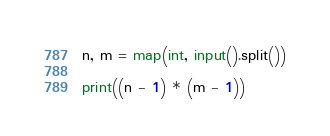<code> <loc_0><loc_0><loc_500><loc_500><_Python_>n, m = map(int, input().split())

print((n - 1) * (m - 1))</code> 